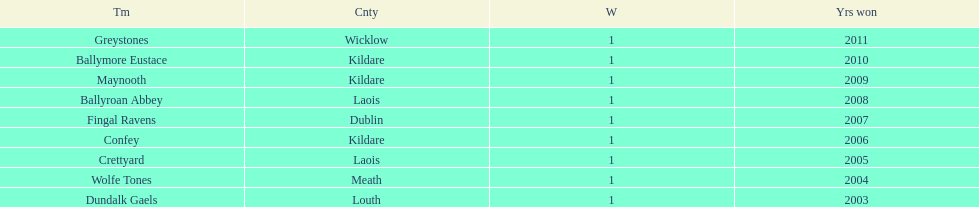Could you help me parse every detail presented in this table? {'header': ['Tm', 'Cnty', 'W', 'Yrs won'], 'rows': [['Greystones', 'Wicklow', '1', '2011'], ['Ballymore Eustace', 'Kildare', '1', '2010'], ['Maynooth', 'Kildare', '1', '2009'], ['Ballyroan Abbey', 'Laois', '1', '2008'], ['Fingal Ravens', 'Dublin', '1', '2007'], ['Confey', 'Kildare', '1', '2006'], ['Crettyard', 'Laois', '1', '2005'], ['Wolfe Tones', 'Meath', '1', '2004'], ['Dundalk Gaels', 'Louth', '1', '2003']]} Which team secured the title preceding ballyroan abbey in 2008? Fingal Ravens. 